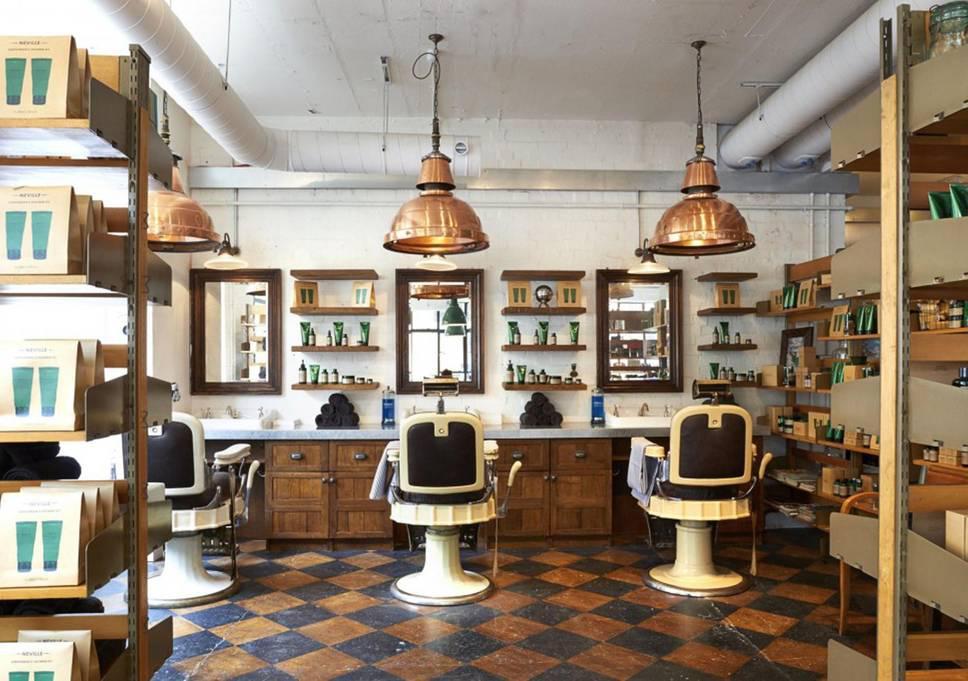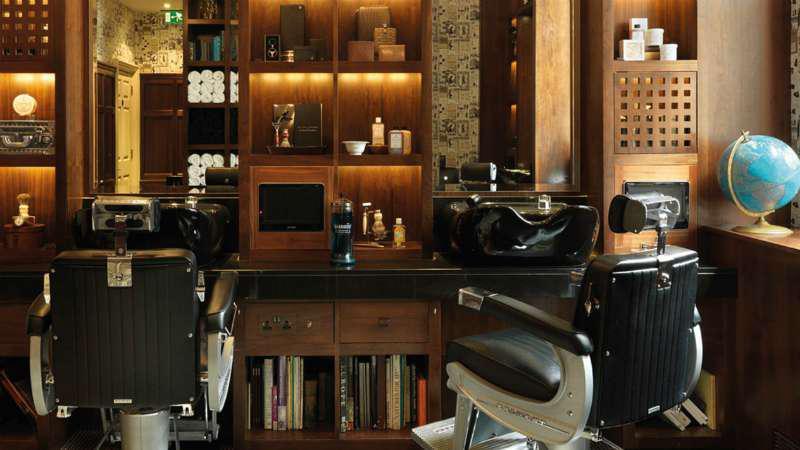The first image is the image on the left, the second image is the image on the right. Examine the images to the left and right. Is the description "In one image, men sit with their backs to the camera in front of tall rectangular wood framed mirrors." accurate? Answer yes or no. No. The first image is the image on the left, the second image is the image on the right. For the images displayed, is the sentence "In at least one image there are a total of two black barber chairs." factually correct? Answer yes or no. Yes. 